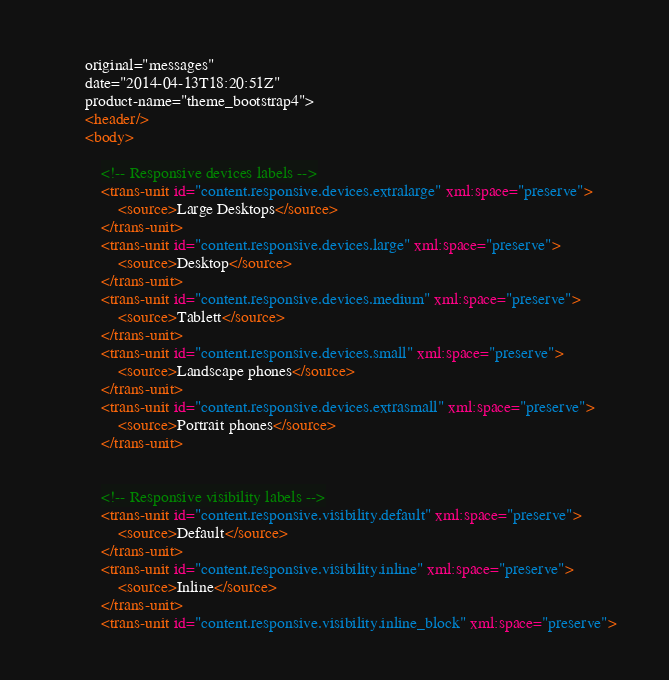Convert code to text. <code><loc_0><loc_0><loc_500><loc_500><_XML_>		original="messages"
		date="2014-04-13T18:20:51Z"
		product-name="theme_bootstrap4">
		<header/>
		<body>

			<!-- Responsive devices labels -->
			<trans-unit id="content.responsive.devices.extralarge" xml:space="preserve">
				<source>Large Desktops</source>
			</trans-unit>
			<trans-unit id="content.responsive.devices.large" xml:space="preserve">
				<source>Desktop</source>
			</trans-unit>
			<trans-unit id="content.responsive.devices.medium" xml:space="preserve">
				<source>Tablett</source>
			</trans-unit>
			<trans-unit id="content.responsive.devices.small" xml:space="preserve">
				<source>Landscape phones</source>
			</trans-unit>
			<trans-unit id="content.responsive.devices.extrasmall" xml:space="preserve">
				<source>Portrait phones</source>
			</trans-unit>

			
			<!-- Responsive visibility labels -->
			<trans-unit id="content.responsive.visibility.default" xml:space="preserve">
				<source>Default</source>
			</trans-unit>
			<trans-unit id="content.responsive.visibility.inline" xml:space="preserve">
				<source>Inline</source>
			</trans-unit>
			<trans-unit id="content.responsive.visibility.inline_block" xml:space="preserve"></code> 